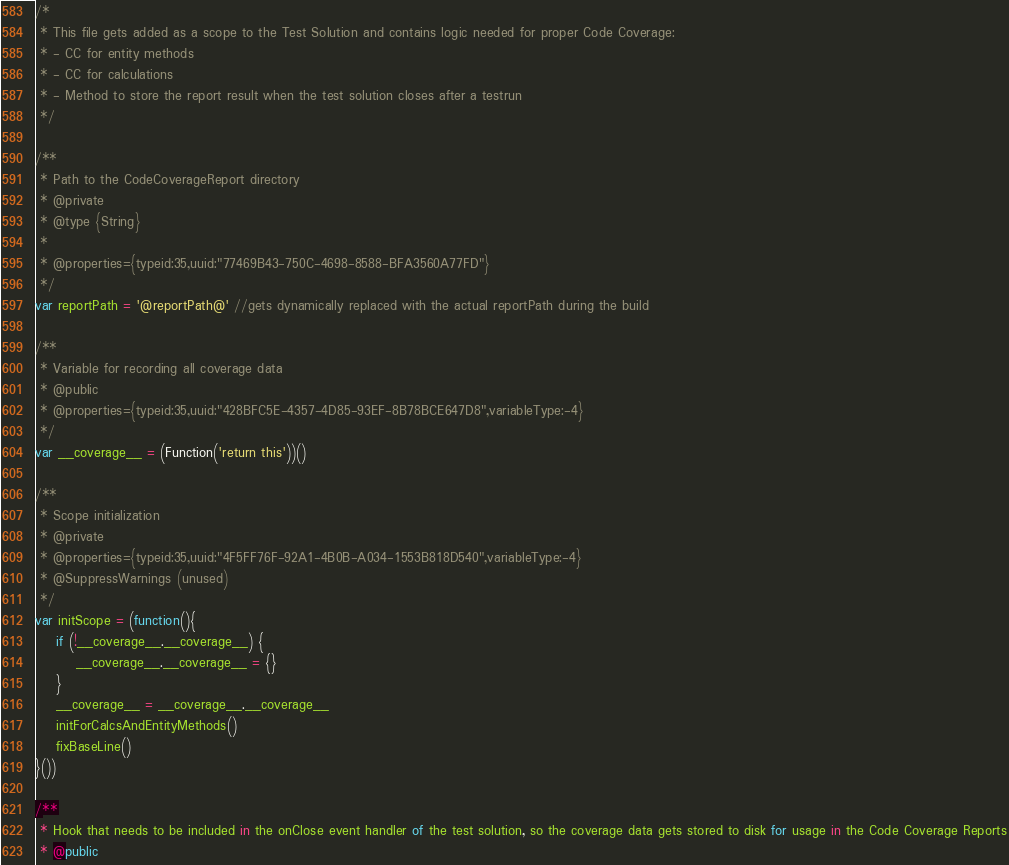<code> <loc_0><loc_0><loc_500><loc_500><_JavaScript_>/*
 * This file gets added as a scope to the Test Solution and contains logic needed for proper Code Coverage:
 * - CC for entity methods
 * - CC for calculations
 * - Method to store the report result when the test solution closes after a testrun
 */

/**
 * Path to the CodeCoverageReport directory
 * @private
 * @type {String}
 *
 * @properties={typeid:35,uuid:"77469B43-750C-4698-8588-BFA3560A77FD"}
 */
var reportPath = '@reportPath@' //gets dynamically replaced with the actual reportPath during the build

/**
 * Variable for recording all coverage data
 * @public
 * @properties={typeid:35,uuid:"428BFC5E-4357-4D85-93EF-8B78BCE647D8",variableType:-4}
 */
var __coverage__ = (Function('return this'))()

/**
 * Scope initialization
 * @private
 * @properties={typeid:35,uuid:"4F5FF76F-92A1-4B0B-A034-1553B818D540",variableType:-4}
 * @SuppressWarnings (unused)
 */
var initScope = (function(){
	if (!__coverage__.__coverage__) {
		__coverage__.__coverage__ = {}
	}
	__coverage__ = __coverage__.__coverage__
	initForCalcsAndEntityMethods()
	fixBaseLine()
}())

/**
 * Hook that needs to be included in the onClose event handler of the test solution, so the coverage data gets stored to disk for usage in the Code Coverage Reports
 * @public</code> 